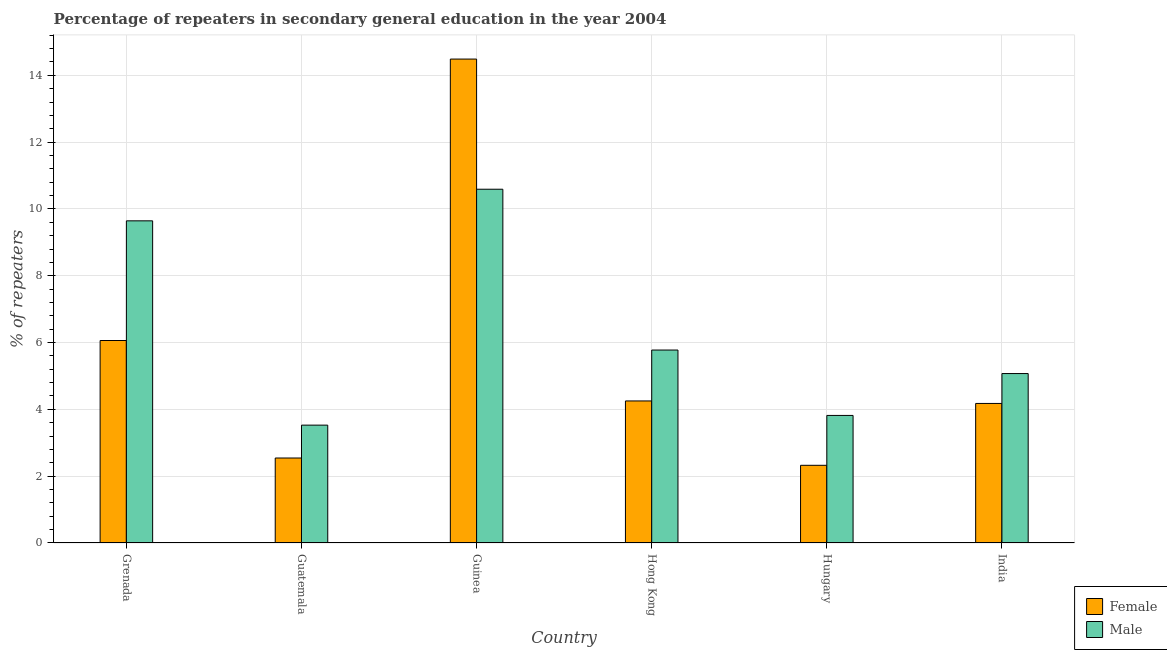Are the number of bars per tick equal to the number of legend labels?
Keep it short and to the point. Yes. What is the label of the 5th group of bars from the left?
Your answer should be very brief. Hungary. In how many cases, is the number of bars for a given country not equal to the number of legend labels?
Offer a terse response. 0. What is the percentage of female repeaters in India?
Ensure brevity in your answer.  4.18. Across all countries, what is the maximum percentage of male repeaters?
Ensure brevity in your answer.  10.59. Across all countries, what is the minimum percentage of male repeaters?
Give a very brief answer. 3.53. In which country was the percentage of male repeaters maximum?
Provide a succinct answer. Guinea. In which country was the percentage of male repeaters minimum?
Make the answer very short. Guatemala. What is the total percentage of male repeaters in the graph?
Make the answer very short. 38.43. What is the difference between the percentage of male repeaters in Guatemala and that in Hong Kong?
Keep it short and to the point. -2.25. What is the difference between the percentage of male repeaters in India and the percentage of female repeaters in Guatemala?
Provide a short and direct response. 2.53. What is the average percentage of female repeaters per country?
Your answer should be very brief. 5.64. What is the difference between the percentage of female repeaters and percentage of male repeaters in Guinea?
Your response must be concise. 3.9. What is the ratio of the percentage of male repeaters in Guatemala to that in Hong Kong?
Make the answer very short. 0.61. Is the difference between the percentage of male repeaters in Guinea and Hong Kong greater than the difference between the percentage of female repeaters in Guinea and Hong Kong?
Provide a short and direct response. No. What is the difference between the highest and the second highest percentage of female repeaters?
Provide a succinct answer. 8.42. What is the difference between the highest and the lowest percentage of male repeaters?
Offer a terse response. 7.06. In how many countries, is the percentage of female repeaters greater than the average percentage of female repeaters taken over all countries?
Provide a succinct answer. 2. What does the 1st bar from the left in Hungary represents?
Offer a terse response. Female. What does the 2nd bar from the right in Guatemala represents?
Give a very brief answer. Female. Are all the bars in the graph horizontal?
Offer a very short reply. No. How many countries are there in the graph?
Provide a succinct answer. 6. Does the graph contain any zero values?
Provide a succinct answer. No. Does the graph contain grids?
Your response must be concise. Yes. Where does the legend appear in the graph?
Keep it short and to the point. Bottom right. How are the legend labels stacked?
Your response must be concise. Vertical. What is the title of the graph?
Make the answer very short. Percentage of repeaters in secondary general education in the year 2004. What is the label or title of the X-axis?
Make the answer very short. Country. What is the label or title of the Y-axis?
Offer a terse response. % of repeaters. What is the % of repeaters in Female in Grenada?
Your answer should be very brief. 6.06. What is the % of repeaters of Male in Grenada?
Make the answer very short. 9.64. What is the % of repeaters in Female in Guatemala?
Offer a terse response. 2.54. What is the % of repeaters in Male in Guatemala?
Your response must be concise. 3.53. What is the % of repeaters in Female in Guinea?
Your answer should be compact. 14.49. What is the % of repeaters in Male in Guinea?
Offer a very short reply. 10.59. What is the % of repeaters in Female in Hong Kong?
Offer a terse response. 4.25. What is the % of repeaters of Male in Hong Kong?
Give a very brief answer. 5.78. What is the % of repeaters in Female in Hungary?
Give a very brief answer. 2.33. What is the % of repeaters of Male in Hungary?
Your response must be concise. 3.82. What is the % of repeaters in Female in India?
Make the answer very short. 4.18. What is the % of repeaters of Male in India?
Offer a very short reply. 5.07. Across all countries, what is the maximum % of repeaters in Female?
Make the answer very short. 14.49. Across all countries, what is the maximum % of repeaters in Male?
Ensure brevity in your answer.  10.59. Across all countries, what is the minimum % of repeaters in Female?
Offer a terse response. 2.33. Across all countries, what is the minimum % of repeaters of Male?
Offer a terse response. 3.53. What is the total % of repeaters of Female in the graph?
Provide a succinct answer. 33.84. What is the total % of repeaters in Male in the graph?
Your answer should be compact. 38.43. What is the difference between the % of repeaters in Female in Grenada and that in Guatemala?
Offer a terse response. 3.52. What is the difference between the % of repeaters in Male in Grenada and that in Guatemala?
Your answer should be compact. 6.12. What is the difference between the % of repeaters of Female in Grenada and that in Guinea?
Keep it short and to the point. -8.42. What is the difference between the % of repeaters of Male in Grenada and that in Guinea?
Give a very brief answer. -0.95. What is the difference between the % of repeaters in Female in Grenada and that in Hong Kong?
Your answer should be compact. 1.81. What is the difference between the % of repeaters of Male in Grenada and that in Hong Kong?
Provide a succinct answer. 3.87. What is the difference between the % of repeaters of Female in Grenada and that in Hungary?
Make the answer very short. 3.74. What is the difference between the % of repeaters of Male in Grenada and that in Hungary?
Offer a very short reply. 5.83. What is the difference between the % of repeaters in Female in Grenada and that in India?
Your response must be concise. 1.88. What is the difference between the % of repeaters in Male in Grenada and that in India?
Your answer should be compact. 4.57. What is the difference between the % of repeaters in Female in Guatemala and that in Guinea?
Your answer should be compact. -11.94. What is the difference between the % of repeaters in Male in Guatemala and that in Guinea?
Your answer should be compact. -7.06. What is the difference between the % of repeaters in Female in Guatemala and that in Hong Kong?
Ensure brevity in your answer.  -1.71. What is the difference between the % of repeaters in Male in Guatemala and that in Hong Kong?
Ensure brevity in your answer.  -2.25. What is the difference between the % of repeaters in Female in Guatemala and that in Hungary?
Your response must be concise. 0.22. What is the difference between the % of repeaters in Male in Guatemala and that in Hungary?
Give a very brief answer. -0.29. What is the difference between the % of repeaters of Female in Guatemala and that in India?
Ensure brevity in your answer.  -1.63. What is the difference between the % of repeaters in Male in Guatemala and that in India?
Offer a terse response. -1.54. What is the difference between the % of repeaters of Female in Guinea and that in Hong Kong?
Offer a very short reply. 10.23. What is the difference between the % of repeaters in Male in Guinea and that in Hong Kong?
Your answer should be compact. 4.81. What is the difference between the % of repeaters in Female in Guinea and that in Hungary?
Your response must be concise. 12.16. What is the difference between the % of repeaters in Male in Guinea and that in Hungary?
Give a very brief answer. 6.77. What is the difference between the % of repeaters in Female in Guinea and that in India?
Make the answer very short. 10.31. What is the difference between the % of repeaters in Male in Guinea and that in India?
Your answer should be compact. 5.52. What is the difference between the % of repeaters of Female in Hong Kong and that in Hungary?
Offer a terse response. 1.93. What is the difference between the % of repeaters of Male in Hong Kong and that in Hungary?
Make the answer very short. 1.96. What is the difference between the % of repeaters of Female in Hong Kong and that in India?
Provide a succinct answer. 0.07. What is the difference between the % of repeaters of Male in Hong Kong and that in India?
Offer a very short reply. 0.7. What is the difference between the % of repeaters in Female in Hungary and that in India?
Your response must be concise. -1.85. What is the difference between the % of repeaters of Male in Hungary and that in India?
Ensure brevity in your answer.  -1.25. What is the difference between the % of repeaters of Female in Grenada and the % of repeaters of Male in Guatemala?
Your answer should be very brief. 2.53. What is the difference between the % of repeaters of Female in Grenada and the % of repeaters of Male in Guinea?
Make the answer very short. -4.53. What is the difference between the % of repeaters of Female in Grenada and the % of repeaters of Male in Hong Kong?
Offer a terse response. 0.29. What is the difference between the % of repeaters in Female in Grenada and the % of repeaters in Male in Hungary?
Give a very brief answer. 2.24. What is the difference between the % of repeaters in Female in Guatemala and the % of repeaters in Male in Guinea?
Your answer should be compact. -8.05. What is the difference between the % of repeaters of Female in Guatemala and the % of repeaters of Male in Hong Kong?
Offer a terse response. -3.23. What is the difference between the % of repeaters in Female in Guatemala and the % of repeaters in Male in Hungary?
Provide a short and direct response. -1.27. What is the difference between the % of repeaters in Female in Guatemala and the % of repeaters in Male in India?
Your response must be concise. -2.53. What is the difference between the % of repeaters in Female in Guinea and the % of repeaters in Male in Hong Kong?
Ensure brevity in your answer.  8.71. What is the difference between the % of repeaters in Female in Guinea and the % of repeaters in Male in Hungary?
Your answer should be very brief. 10.67. What is the difference between the % of repeaters of Female in Guinea and the % of repeaters of Male in India?
Ensure brevity in your answer.  9.41. What is the difference between the % of repeaters in Female in Hong Kong and the % of repeaters in Male in Hungary?
Your response must be concise. 0.43. What is the difference between the % of repeaters of Female in Hong Kong and the % of repeaters of Male in India?
Your answer should be very brief. -0.82. What is the difference between the % of repeaters in Female in Hungary and the % of repeaters in Male in India?
Keep it short and to the point. -2.75. What is the average % of repeaters in Female per country?
Give a very brief answer. 5.64. What is the average % of repeaters of Male per country?
Provide a short and direct response. 6.4. What is the difference between the % of repeaters in Female and % of repeaters in Male in Grenada?
Your answer should be compact. -3.58. What is the difference between the % of repeaters of Female and % of repeaters of Male in Guatemala?
Offer a terse response. -0.98. What is the difference between the % of repeaters of Female and % of repeaters of Male in Guinea?
Offer a terse response. 3.9. What is the difference between the % of repeaters of Female and % of repeaters of Male in Hong Kong?
Provide a short and direct response. -1.52. What is the difference between the % of repeaters in Female and % of repeaters in Male in Hungary?
Offer a very short reply. -1.49. What is the difference between the % of repeaters in Female and % of repeaters in Male in India?
Your answer should be compact. -0.89. What is the ratio of the % of repeaters of Female in Grenada to that in Guatemala?
Make the answer very short. 2.38. What is the ratio of the % of repeaters in Male in Grenada to that in Guatemala?
Your answer should be very brief. 2.73. What is the ratio of the % of repeaters of Female in Grenada to that in Guinea?
Keep it short and to the point. 0.42. What is the ratio of the % of repeaters of Male in Grenada to that in Guinea?
Ensure brevity in your answer.  0.91. What is the ratio of the % of repeaters of Female in Grenada to that in Hong Kong?
Offer a very short reply. 1.43. What is the ratio of the % of repeaters of Male in Grenada to that in Hong Kong?
Your response must be concise. 1.67. What is the ratio of the % of repeaters in Female in Grenada to that in Hungary?
Provide a succinct answer. 2.61. What is the ratio of the % of repeaters of Male in Grenada to that in Hungary?
Offer a very short reply. 2.53. What is the ratio of the % of repeaters of Female in Grenada to that in India?
Provide a short and direct response. 1.45. What is the ratio of the % of repeaters in Male in Grenada to that in India?
Provide a short and direct response. 1.9. What is the ratio of the % of repeaters of Female in Guatemala to that in Guinea?
Provide a short and direct response. 0.18. What is the ratio of the % of repeaters of Male in Guatemala to that in Guinea?
Your answer should be compact. 0.33. What is the ratio of the % of repeaters of Female in Guatemala to that in Hong Kong?
Keep it short and to the point. 0.6. What is the ratio of the % of repeaters of Male in Guatemala to that in Hong Kong?
Make the answer very short. 0.61. What is the ratio of the % of repeaters in Female in Guatemala to that in Hungary?
Ensure brevity in your answer.  1.09. What is the ratio of the % of repeaters in Male in Guatemala to that in Hungary?
Your answer should be very brief. 0.92. What is the ratio of the % of repeaters in Female in Guatemala to that in India?
Give a very brief answer. 0.61. What is the ratio of the % of repeaters in Male in Guatemala to that in India?
Ensure brevity in your answer.  0.7. What is the ratio of the % of repeaters in Female in Guinea to that in Hong Kong?
Provide a succinct answer. 3.41. What is the ratio of the % of repeaters in Male in Guinea to that in Hong Kong?
Keep it short and to the point. 1.83. What is the ratio of the % of repeaters of Female in Guinea to that in Hungary?
Offer a very short reply. 6.23. What is the ratio of the % of repeaters in Male in Guinea to that in Hungary?
Keep it short and to the point. 2.77. What is the ratio of the % of repeaters of Female in Guinea to that in India?
Offer a very short reply. 3.47. What is the ratio of the % of repeaters of Male in Guinea to that in India?
Offer a terse response. 2.09. What is the ratio of the % of repeaters in Female in Hong Kong to that in Hungary?
Make the answer very short. 1.83. What is the ratio of the % of repeaters in Male in Hong Kong to that in Hungary?
Give a very brief answer. 1.51. What is the ratio of the % of repeaters of Male in Hong Kong to that in India?
Provide a short and direct response. 1.14. What is the ratio of the % of repeaters in Female in Hungary to that in India?
Provide a short and direct response. 0.56. What is the ratio of the % of repeaters in Male in Hungary to that in India?
Your response must be concise. 0.75. What is the difference between the highest and the second highest % of repeaters of Female?
Make the answer very short. 8.42. What is the difference between the highest and the second highest % of repeaters of Male?
Your response must be concise. 0.95. What is the difference between the highest and the lowest % of repeaters in Female?
Offer a very short reply. 12.16. What is the difference between the highest and the lowest % of repeaters in Male?
Provide a succinct answer. 7.06. 